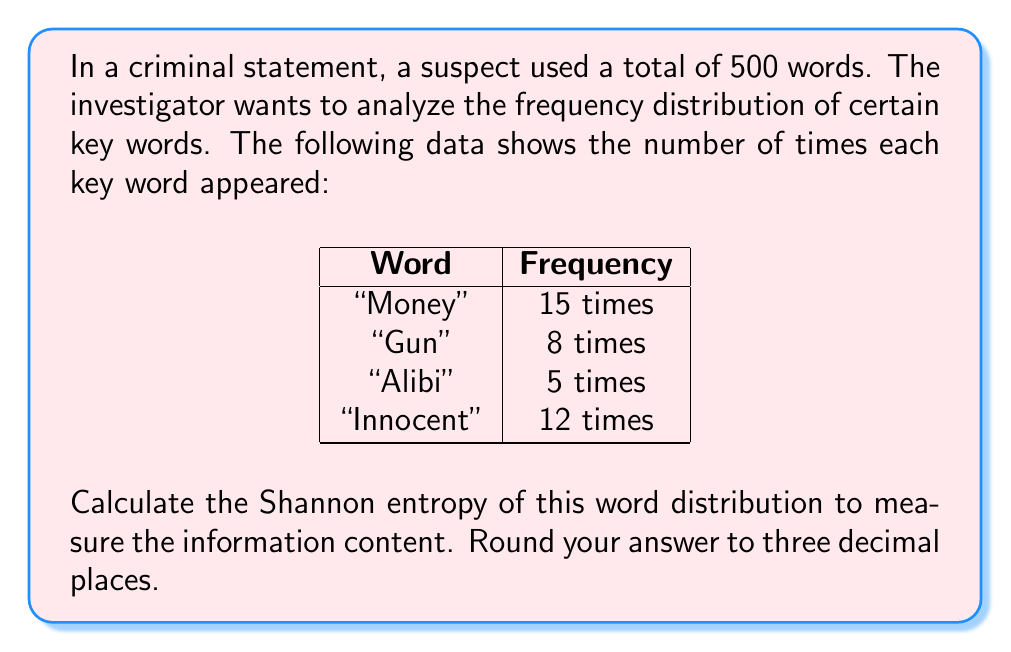Help me with this question. To calculate the Shannon entropy of the word distribution, we'll follow these steps:

1. Calculate the probability of each word occurring:
   $p(\text{Money}) = \frac{15}{40} = 0.375$
   $p(\text{Gun}) = \frac{8}{40} = 0.2$
   $p(\text{Alibi}) = \frac{5}{40} = 0.125$
   $p(\text{Innocent}) = \frac{12}{40} = 0.3$

2. Apply the Shannon entropy formula:
   $$H = -\sum_{i=1}^n p_i \log_2(p_i)$$
   where $p_i$ is the probability of each word and $n$ is the number of words.

3. Calculate each term:
   $-0.375 \log_2(0.375) = 0.53089$
   $-0.2 \log_2(0.2) = 0.46439$
   $-0.125 \log_2(0.125) = 0.37533$
   $-0.3 \log_2(0.3) = 0.52108$

4. Sum all terms:
   $H = 0.53089 + 0.46439 + 0.37533 + 0.52108 = 1.89169$

5. Round to three decimal places:
   $H \approx 1.892$

The Shannon entropy of 1.892 bits indicates the average amount of information conveyed by each word in this distribution.
Answer: 1.892 bits 